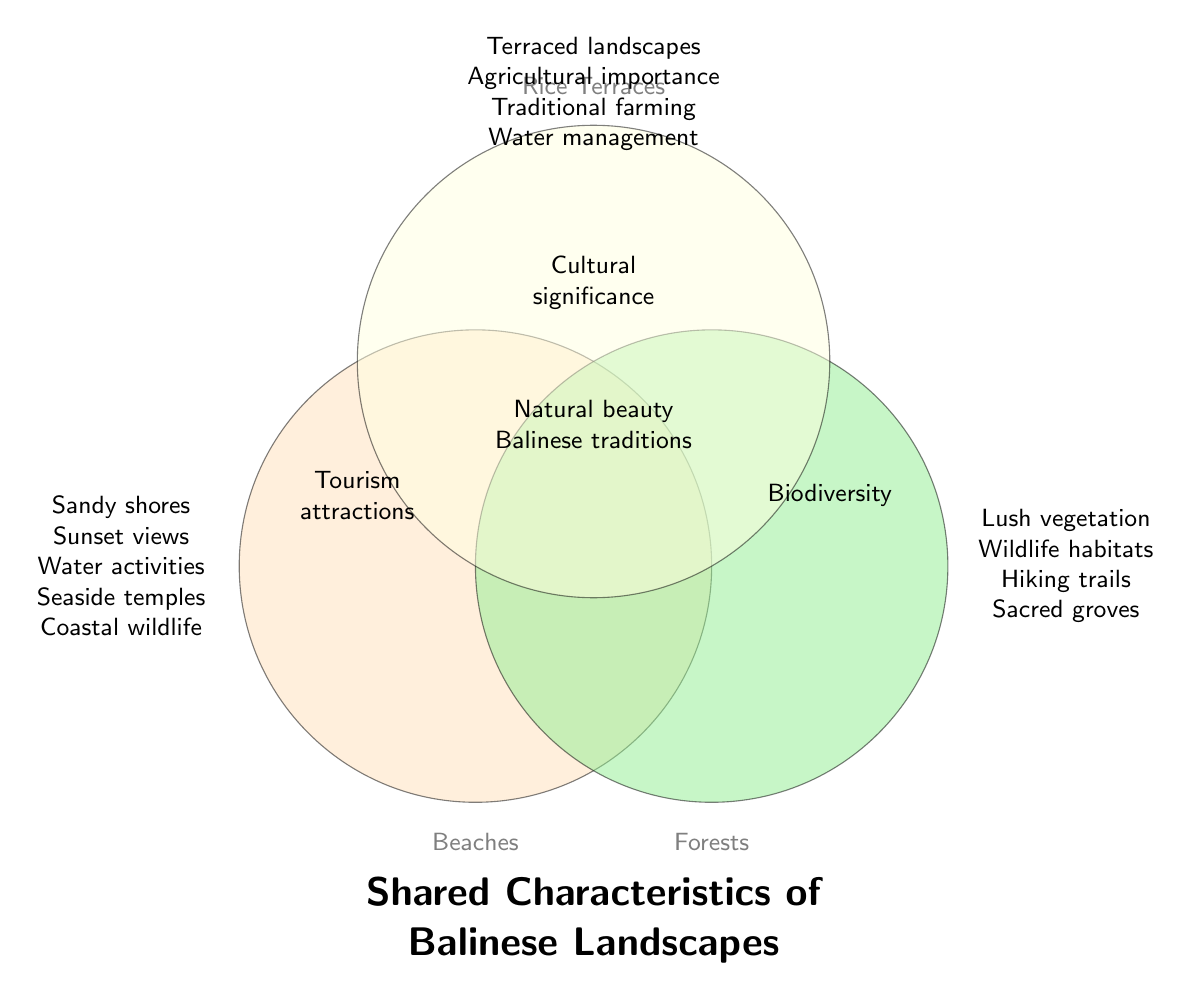What are the defining features of Balinese beaches? The features listed under the "Beaches" section include sandy shores, sunset views, water activities, seaside temples, and coastal wildlife.
Answer: Sandy shores, sunset views, water activities, seaside temples, coastal wildlife What characteristic is shared by all three landscapes? The central part of the Venn diagram, intersecting all three circles, lists "Natural beauty" and "Balinese traditions".
Answer: Natural beauty, Balinese traditions Which type of landscape includes sacred groves? Sacred groves are mentioned under the "Forests" section.
Answer: Forests What activities can tourists enjoy at both Balinese beaches and rice terraces? The overlapping section between "Beaches" and "Rice Terraces" includes "Tourism attractions".
Answer: Tourism attractions What two features are found in both forests and rice terraces? The intersection between "Forests" and "Rice Terraces" lists "Biodiversity" and "Cultural significance".
Answer: Biodiversity, Cultural significance Which landscape types are associated with "Water management"? "Water management" is listed under the "Rice Terraces" section.
Answer: Rice Terraces What feature is unique to Balinese beaches and not shared with forests or rice terraces? Unique features for beaches, not overlapping with others include sandy shores, sunset views, water activities, seaside temples, and coastal wildlife.
Answer: Sandy shores, sunset views, water activities, seaside temples, coastal wildlife What shared feature is found in both beaches and forests, but not in rice terraces? "Tourism attractions" are found in the intersection between "Beaches" and "Forests".
Answer: Tourism attractions Which landscape is essential for traditional farming? The section under "Rice Terraces" includes "Traditional farming".
Answer: Rice Terraces 